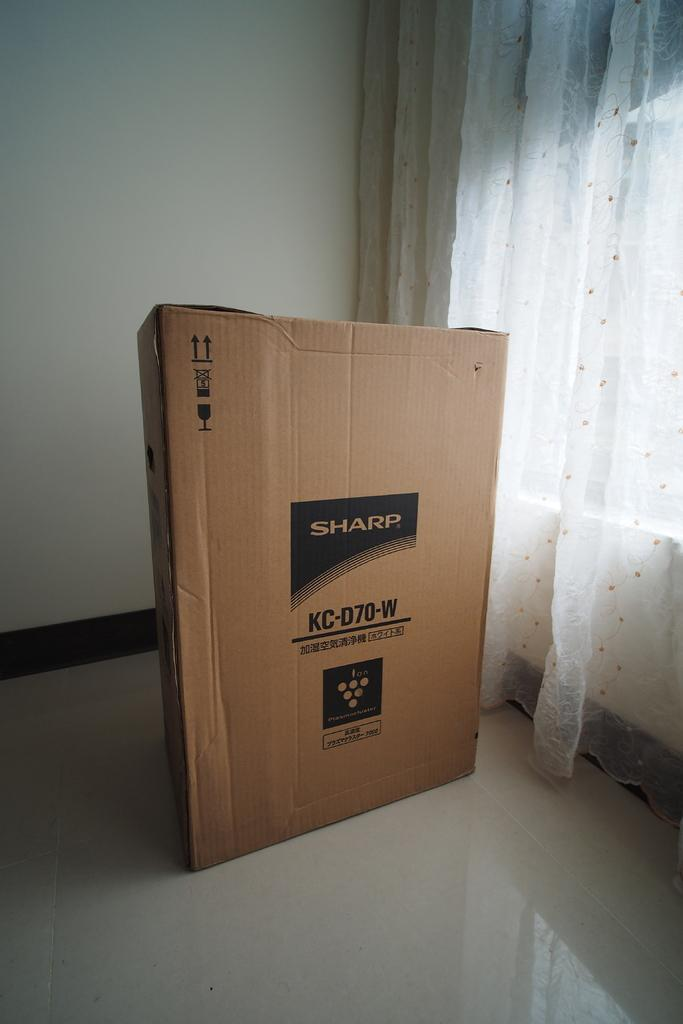<image>
Give a short and clear explanation of the subsequent image. A large box from Sharp sits in an empty room next to some gauzy curtains. 